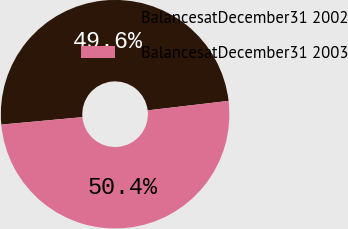<chart> <loc_0><loc_0><loc_500><loc_500><pie_chart><fcel>BalancesatDecember31 2002<fcel>BalancesatDecember31 2003<nl><fcel>49.59%<fcel>50.41%<nl></chart> 